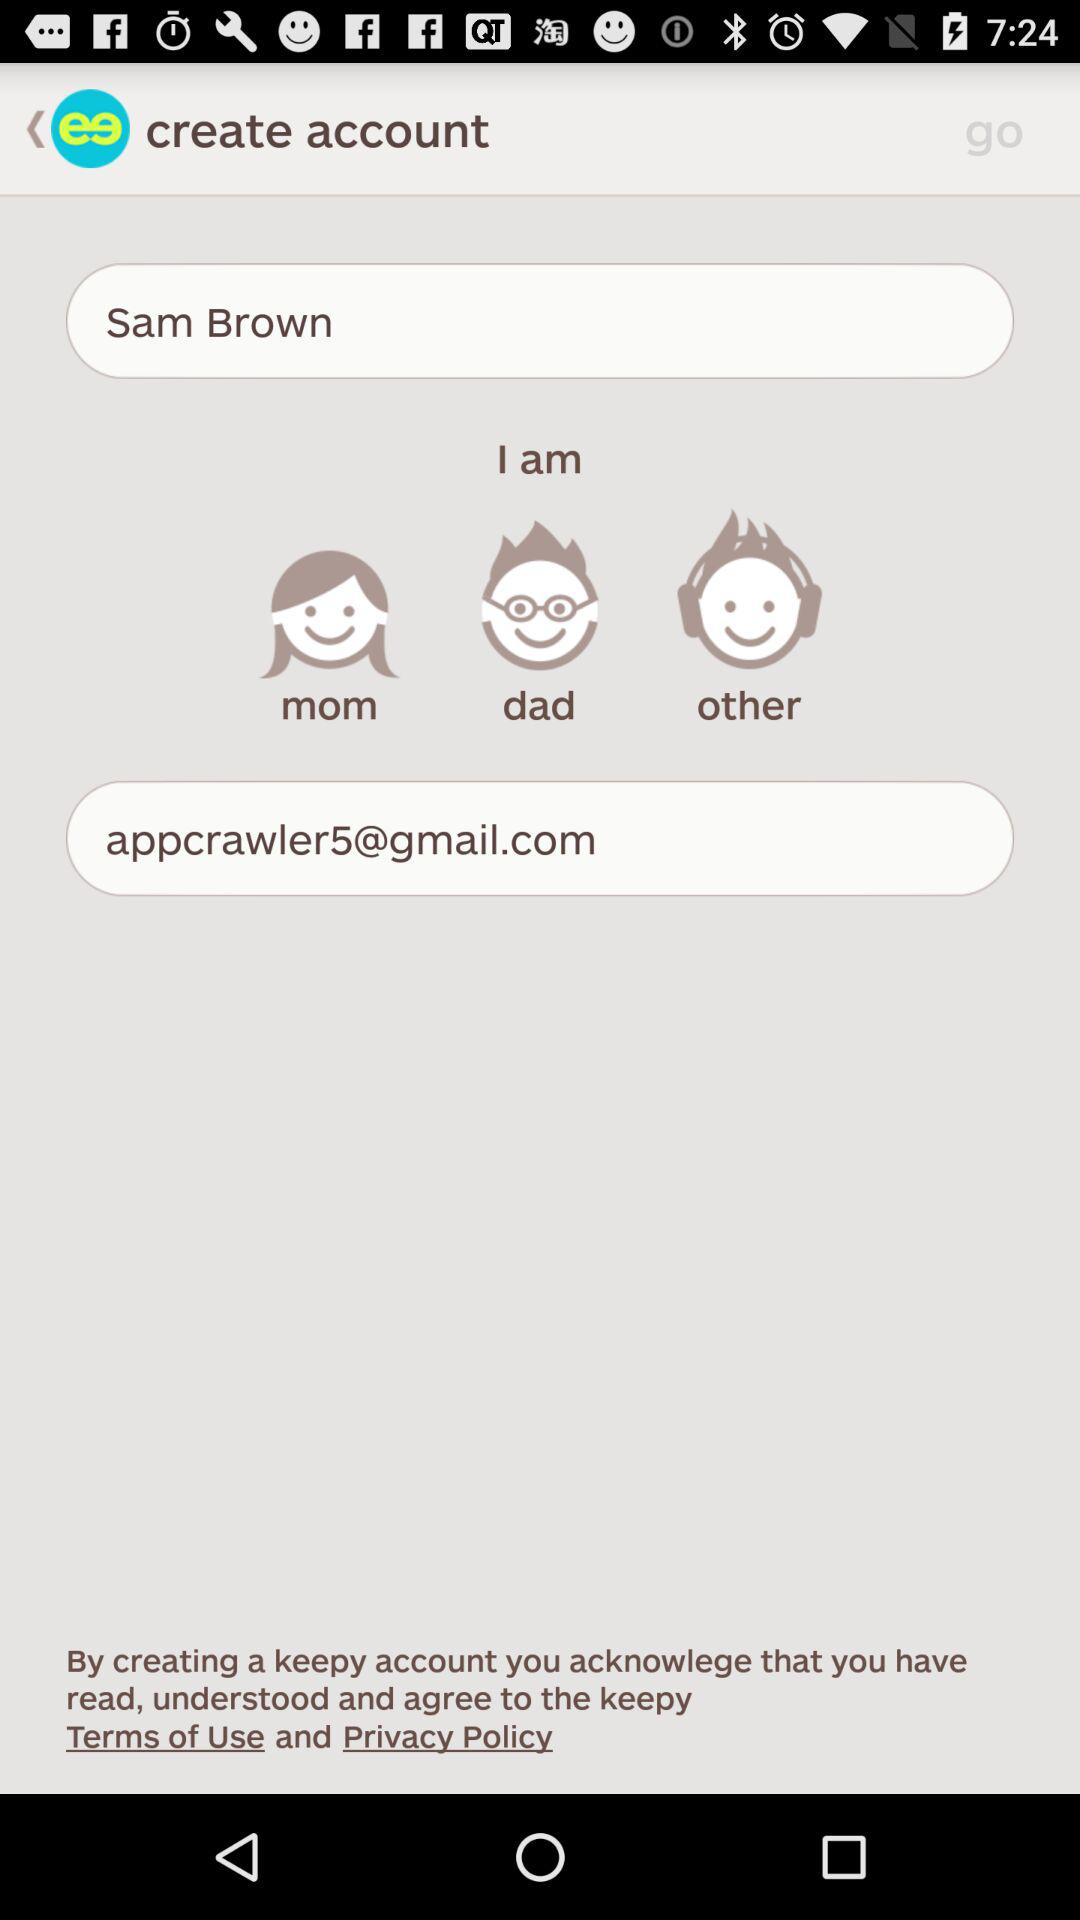What is the entered name? The entered name is Sam Brown. 